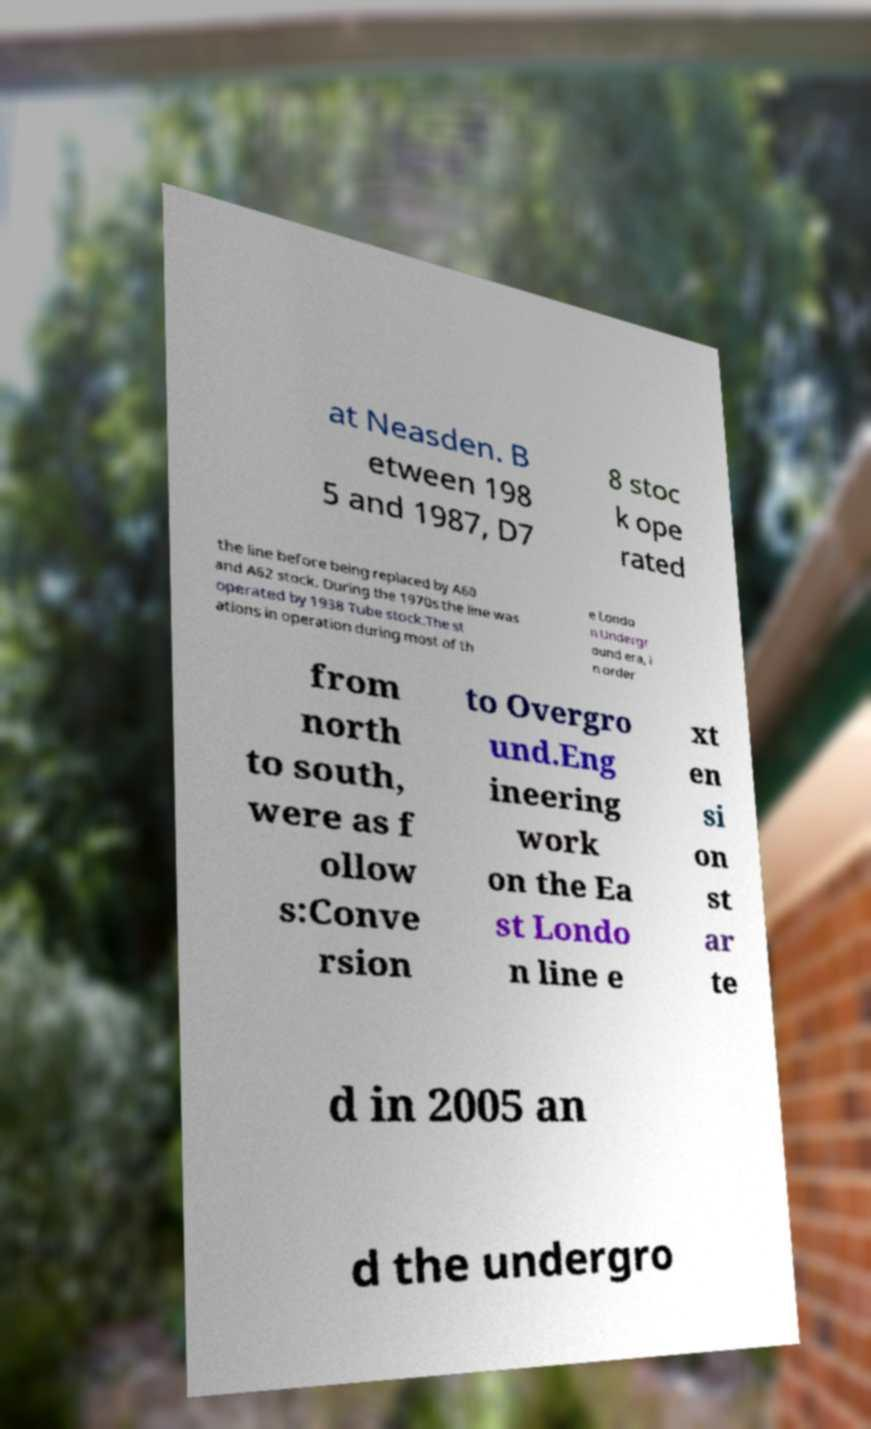There's text embedded in this image that I need extracted. Can you transcribe it verbatim? at Neasden. B etween 198 5 and 1987, D7 8 stoc k ope rated the line before being replaced by A60 and A62 stock. During the 1970s the line was operated by 1938 Tube stock.The st ations in operation during most of th e Londo n Undergr ound era, i n order from north to south, were as f ollow s:Conve rsion to Overgro und.Eng ineering work on the Ea st Londo n line e xt en si on st ar te d in 2005 an d the undergro 